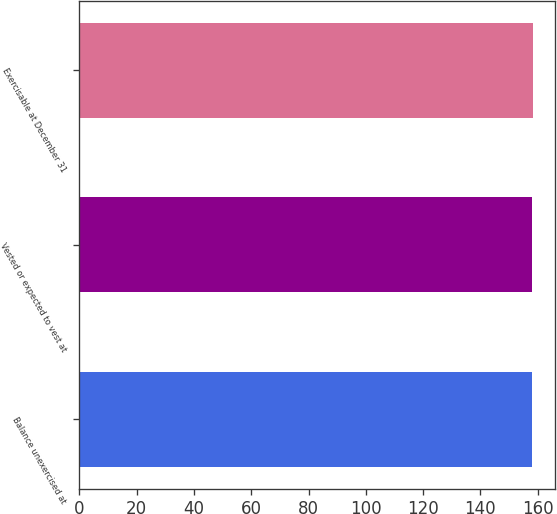Convert chart. <chart><loc_0><loc_0><loc_500><loc_500><bar_chart><fcel>Balance unexercised at<fcel>Vested or expected to vest at<fcel>Exercisable at December 31<nl><fcel>158<fcel>158.1<fcel>158.2<nl></chart> 